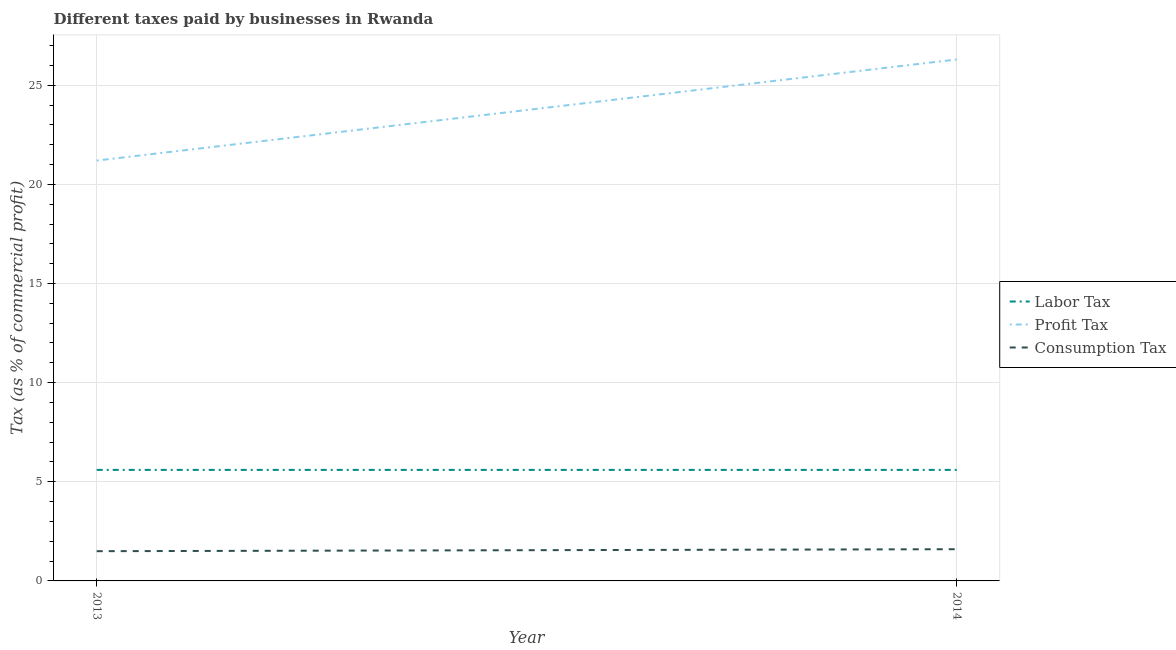Is the number of lines equal to the number of legend labels?
Your answer should be compact. Yes. What is the percentage of labor tax in 2013?
Ensure brevity in your answer.  5.6. Across all years, what is the maximum percentage of profit tax?
Your answer should be compact. 26.3. What is the total percentage of labor tax in the graph?
Ensure brevity in your answer.  11.2. What is the difference between the percentage of consumption tax in 2013 and that in 2014?
Ensure brevity in your answer.  -0.1. What is the difference between the percentage of profit tax in 2013 and the percentage of consumption tax in 2014?
Your answer should be very brief. 19.6. What is the average percentage of profit tax per year?
Offer a terse response. 23.75. In the year 2013, what is the difference between the percentage of labor tax and percentage of profit tax?
Your answer should be compact. -15.6. In how many years, is the percentage of profit tax greater than 23 %?
Provide a succinct answer. 1. Does the percentage of labor tax monotonically increase over the years?
Offer a terse response. No. Is the percentage of profit tax strictly greater than the percentage of consumption tax over the years?
Give a very brief answer. Yes. What is the difference between two consecutive major ticks on the Y-axis?
Offer a very short reply. 5. Are the values on the major ticks of Y-axis written in scientific E-notation?
Offer a terse response. No. Does the graph contain any zero values?
Offer a very short reply. No. Does the graph contain grids?
Provide a succinct answer. Yes. Where does the legend appear in the graph?
Provide a short and direct response. Center right. How many legend labels are there?
Ensure brevity in your answer.  3. How are the legend labels stacked?
Provide a succinct answer. Vertical. What is the title of the graph?
Ensure brevity in your answer.  Different taxes paid by businesses in Rwanda. Does "Labor Tax" appear as one of the legend labels in the graph?
Offer a terse response. Yes. What is the label or title of the X-axis?
Keep it short and to the point. Year. What is the label or title of the Y-axis?
Keep it short and to the point. Tax (as % of commercial profit). What is the Tax (as % of commercial profit) in Profit Tax in 2013?
Your answer should be compact. 21.2. What is the Tax (as % of commercial profit) in Profit Tax in 2014?
Keep it short and to the point. 26.3. What is the Tax (as % of commercial profit) in Consumption Tax in 2014?
Ensure brevity in your answer.  1.6. Across all years, what is the maximum Tax (as % of commercial profit) of Profit Tax?
Ensure brevity in your answer.  26.3. Across all years, what is the maximum Tax (as % of commercial profit) of Consumption Tax?
Give a very brief answer. 1.6. Across all years, what is the minimum Tax (as % of commercial profit) of Profit Tax?
Your answer should be very brief. 21.2. What is the total Tax (as % of commercial profit) of Profit Tax in the graph?
Your answer should be very brief. 47.5. What is the difference between the Tax (as % of commercial profit) of Labor Tax in 2013 and that in 2014?
Provide a short and direct response. 0. What is the difference between the Tax (as % of commercial profit) in Labor Tax in 2013 and the Tax (as % of commercial profit) in Profit Tax in 2014?
Your response must be concise. -20.7. What is the difference between the Tax (as % of commercial profit) in Profit Tax in 2013 and the Tax (as % of commercial profit) in Consumption Tax in 2014?
Your answer should be very brief. 19.6. What is the average Tax (as % of commercial profit) in Profit Tax per year?
Your response must be concise. 23.75. What is the average Tax (as % of commercial profit) in Consumption Tax per year?
Provide a short and direct response. 1.55. In the year 2013, what is the difference between the Tax (as % of commercial profit) of Labor Tax and Tax (as % of commercial profit) of Profit Tax?
Keep it short and to the point. -15.6. In the year 2014, what is the difference between the Tax (as % of commercial profit) in Labor Tax and Tax (as % of commercial profit) in Profit Tax?
Your answer should be very brief. -20.7. In the year 2014, what is the difference between the Tax (as % of commercial profit) of Profit Tax and Tax (as % of commercial profit) of Consumption Tax?
Ensure brevity in your answer.  24.7. What is the ratio of the Tax (as % of commercial profit) in Labor Tax in 2013 to that in 2014?
Offer a very short reply. 1. What is the ratio of the Tax (as % of commercial profit) of Profit Tax in 2013 to that in 2014?
Provide a short and direct response. 0.81. What is the difference between the highest and the second highest Tax (as % of commercial profit) in Labor Tax?
Give a very brief answer. 0. What is the difference between the highest and the second highest Tax (as % of commercial profit) in Profit Tax?
Your response must be concise. 5.1. What is the difference between the highest and the lowest Tax (as % of commercial profit) in Consumption Tax?
Give a very brief answer. 0.1. 